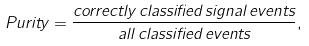<formula> <loc_0><loc_0><loc_500><loc_500>P u r i t y = \frac { c o r r e c t l y \, c l a s s i f i e d \, s i g n a l \, e v e n t s } { a l l \, c l a s s i f i e d \, e v e n t s } ,</formula> 